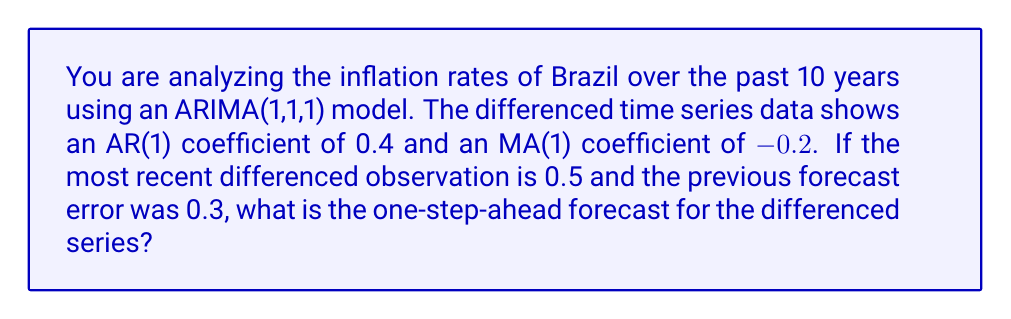Show me your answer to this math problem. To solve this problem, we need to use the ARIMA(1,1,1) model equation. For a differenced series, the general form of an ARIMA(1,1,1) model is:

$$(1 - \phi B)(1 - B)y_t = (1 + \theta B)\epsilon_t$$

Where:
- $\phi$ is the AR(1) coefficient
- $\theta$ is the MA(1) coefficient
- $B$ is the backshift operator
- $y_t$ is the original series
- $\epsilon_t$ is the error term

For forecasting, we use the following equation:

$$\hat{y}_{t+1} = \phi y_t + \epsilon_t - \theta \epsilon_{t-1}$$

Where:
- $\hat{y}_{t+1}$ is the one-step-ahead forecast
- $y_t$ is the most recent observation
- $\epsilon_t$ is the most recent forecast error
- $\epsilon_{t-1}$ is the previous forecast error

Given:
- $\phi = 0.4$ (AR(1) coefficient)
- $\theta = -0.2$ (MA(1) coefficient)
- $y_t = 0.5$ (most recent differenced observation)
- $\epsilon_t = 0.3$ (most recent forecast error)

Step 1: Substitute the given values into the forecasting equation:

$$\hat{y}_{t+1} = 0.4(0.5) + 0.3 - (-0.2)(0.3)$$

Step 2: Calculate each term:
- $0.4(0.5) = 0.2$
- $-(-0.2)(0.3) = 0.06$

Step 3: Sum up all terms:

$$\hat{y}_{t+1} = 0.2 + 0.3 + 0.06 = 0.56$$

Therefore, the one-step-ahead forecast for the differenced series is 0.56.
Answer: 0.56 